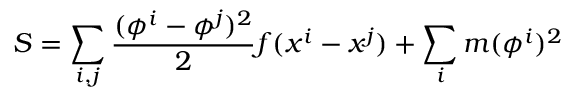<formula> <loc_0><loc_0><loc_500><loc_500>S = \sum _ { i , j } { \frac { ( \phi ^ { i } - \phi ^ { j } ) ^ { 2 } } { 2 } } f ( x ^ { i } - x ^ { j } ) + \sum _ { i } m ( \phi ^ { i } ) ^ { 2 }</formula> 